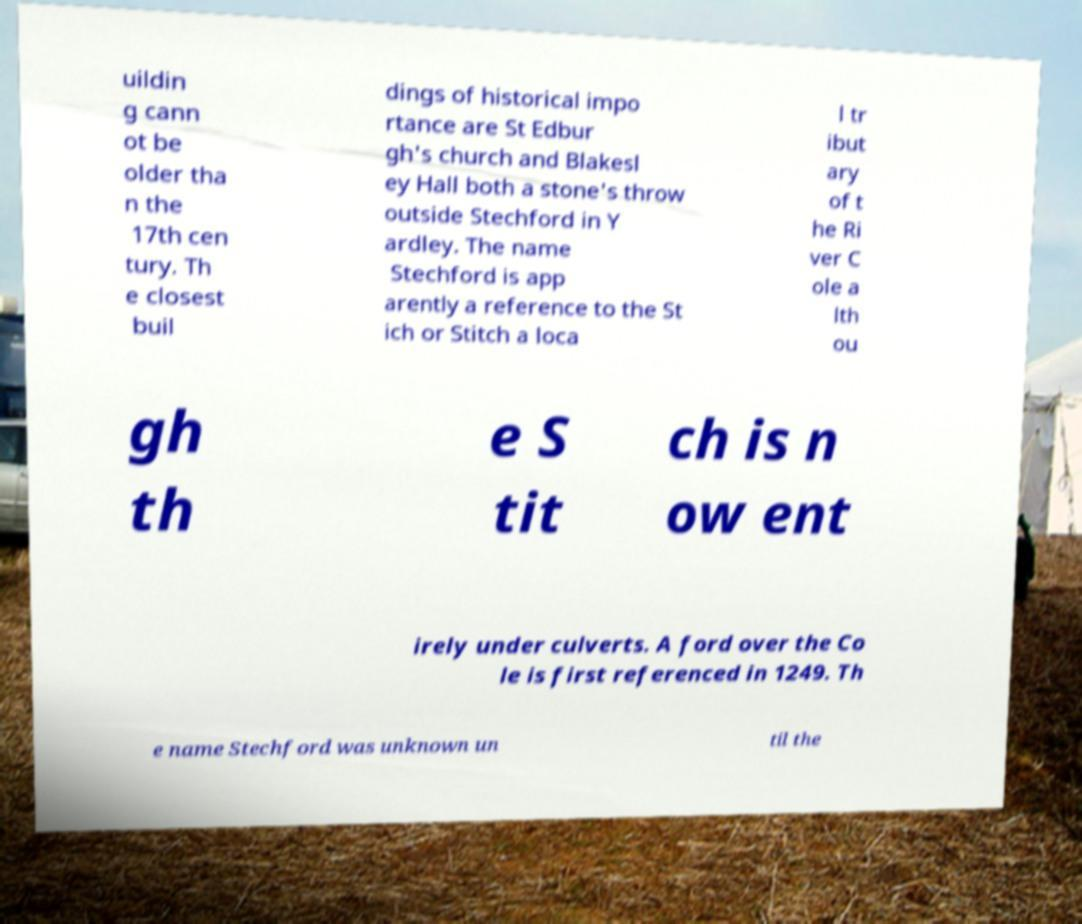I need the written content from this picture converted into text. Can you do that? uildin g cann ot be older tha n the 17th cen tury. Th e closest buil dings of historical impo rtance are St Edbur gh's church and Blakesl ey Hall both a stone's throw outside Stechford in Y ardley. The name Stechford is app arently a reference to the St ich or Stitch a loca l tr ibut ary of t he Ri ver C ole a lth ou gh th e S tit ch is n ow ent irely under culverts. A ford over the Co le is first referenced in 1249. Th e name Stechford was unknown un til the 